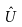Convert formula to latex. <formula><loc_0><loc_0><loc_500><loc_500>\hat { U }</formula> 